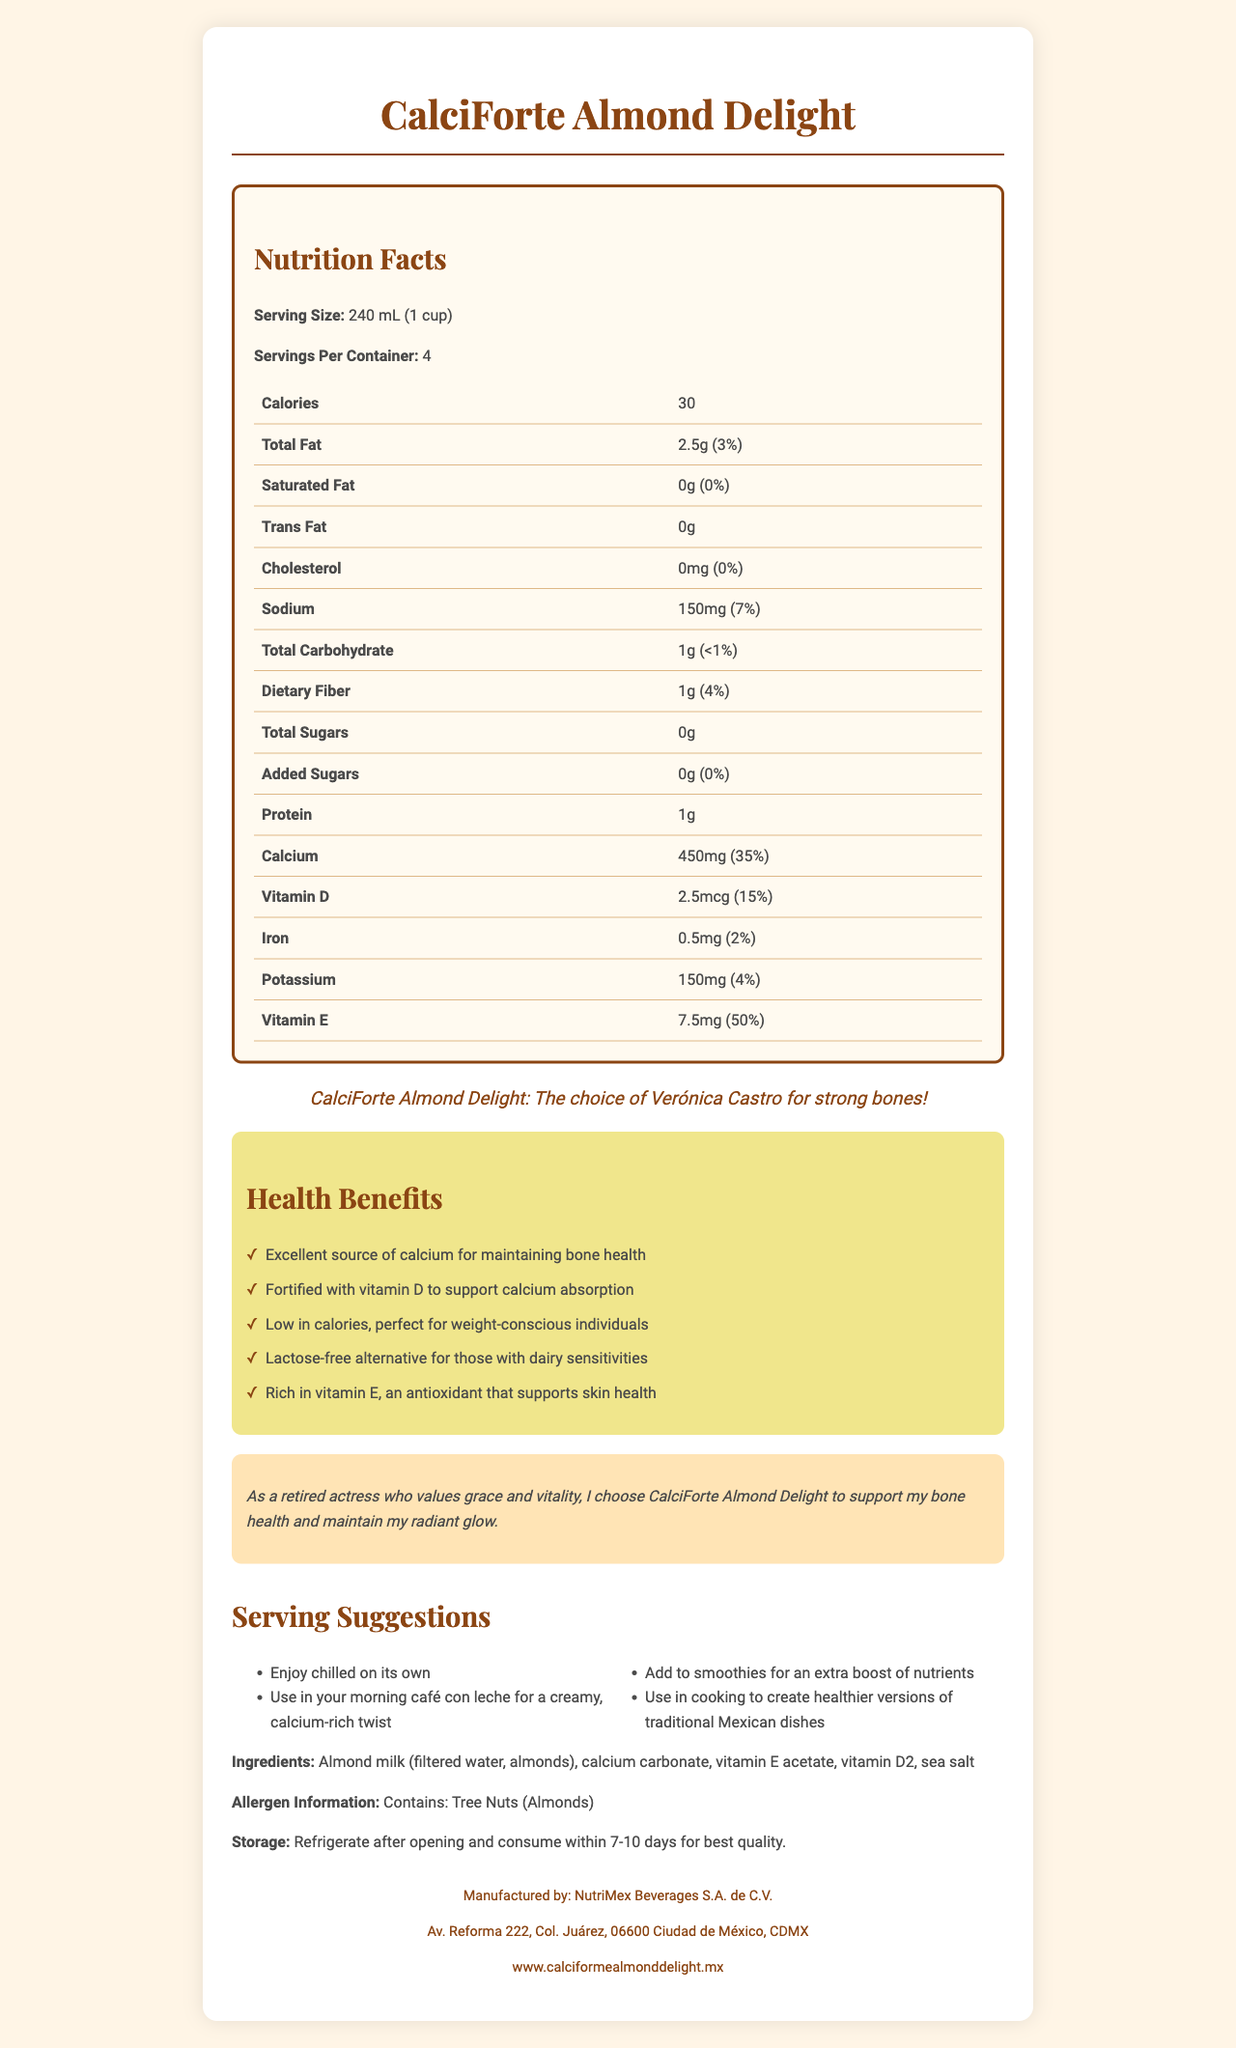what is the serving size of CalciForte Almond Delight? The document states that the serving size is 240 mL, which is equivalent to 1 cup.
Answer: 240 mL (1 cup) how many calories are there per serving? The document lists 30 calories per serving under the Nutrition Facts section.
Answer: 30 how much calcium does one serving provide? The Nutrition Facts table shows that one serving provides 450 mg of calcium.
Answer: 450 mg what is the daily value percentage of vitamin D in one serving? The Nutrition Facts table indicates that one serving contains 15% of the daily value for vitamin D.
Answer: 15% what types of dishes can CalciForte Almond Delight be used in? The serving suggestions include using the beverage in smoothies, morning café con leche, and healthier versions of traditional Mexican dishes.
Answer: Smoothies, morning café con leche, traditional Mexican dishes which of the following best describes the main purpose of this document? A. Promote a dairy alternative B. Provide exercise tips C. Advertise a software product The document is focused on promoting a calcium-fortified almond milk beverage, which is a dairy alternative.
Answer: A what are the primary ingredients in CalciForte Almond Delight? A. Almond milk, vitamin E, sea salt B. Almond milk, sugar, sea salt C. Almond milk, calcium carbonate, vitamin B12 The ingredients list includes almond milk (filtered water, almonds), calcium carbonate, vitamin E acetate, vitamin D2, and sea salt, so option A is correct.
Answer: A does the product contain any added sugars? The Nutrition Facts indicate 0g of added sugars.
Answer: No is CalciForte Almond Delight lactose-free? One of the health claims mentions that the product is a lactose-free alternative for those with dairy sensitivities.
Answer: Yes summarize the document. The document presents a comprehensive overview of CalciForte Almond Delight, focusing on its nutritional advantages, especially for bone health, and offering various serving ideas and lifestyle benefits.
Answer: The document provides detailed information about CalciForte Almond Delight, a calcium-fortified almond milk beverage, highlighting its nutritional content, health benefits, ingredients, allergen info, serving suggestions, brand and lifestyle statements, and manufacturer details. It emphasizes the product's suitability for maintaining bone health, particularly in aging adults, and positions it as a healthy, low-calorie, and lactose-free option. who manufactures CalciForte Almond Delight? The footer provides the manufacturer's name as NutriMex Beverages S.A. de C.V.
Answer: NutriMex Beverages S.A. de C.V. what is the address of the manufacturer? The footer of the document lists the address as Av. Reforma 222, Col. Juárez, 06600 Ciudad de México, CDMX.
Answer: Av. Reforma 222, Col. Juárez, 06600 Ciudad de México, CDMX can this document tell you if the product is available worldwide? The document does not provide any information about the product's availability or distribution beyond the details of the manufacturer.
Answer: Cannot be determined 